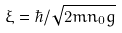Convert formula to latex. <formula><loc_0><loc_0><loc_500><loc_500>\xi = \hbar { / } \sqrt { 2 m n _ { 0 } g }</formula> 